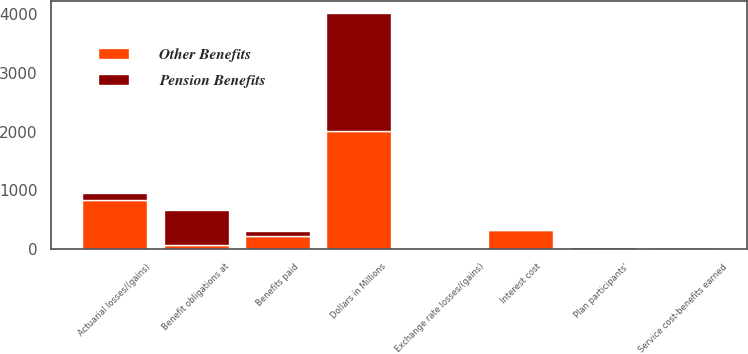Convert chart to OTSL. <chart><loc_0><loc_0><loc_500><loc_500><stacked_bar_chart><ecel><fcel>Dollars in Millions<fcel>Benefit obligations at<fcel>Service cost-benefits earned<fcel>Interest cost<fcel>Plan participants'<fcel>Actuarial losses/(gains)<fcel>Benefits paid<fcel>Exchange rate losses/(gains)<nl><fcel>Other Benefits<fcel>2012<fcel>76<fcel>32<fcel>319<fcel>2<fcel>838<fcel>227<fcel>24<nl><fcel>Pension Benefits<fcel>2012<fcel>582<fcel>8<fcel>22<fcel>24<fcel>107<fcel>76<fcel>1<nl></chart> 